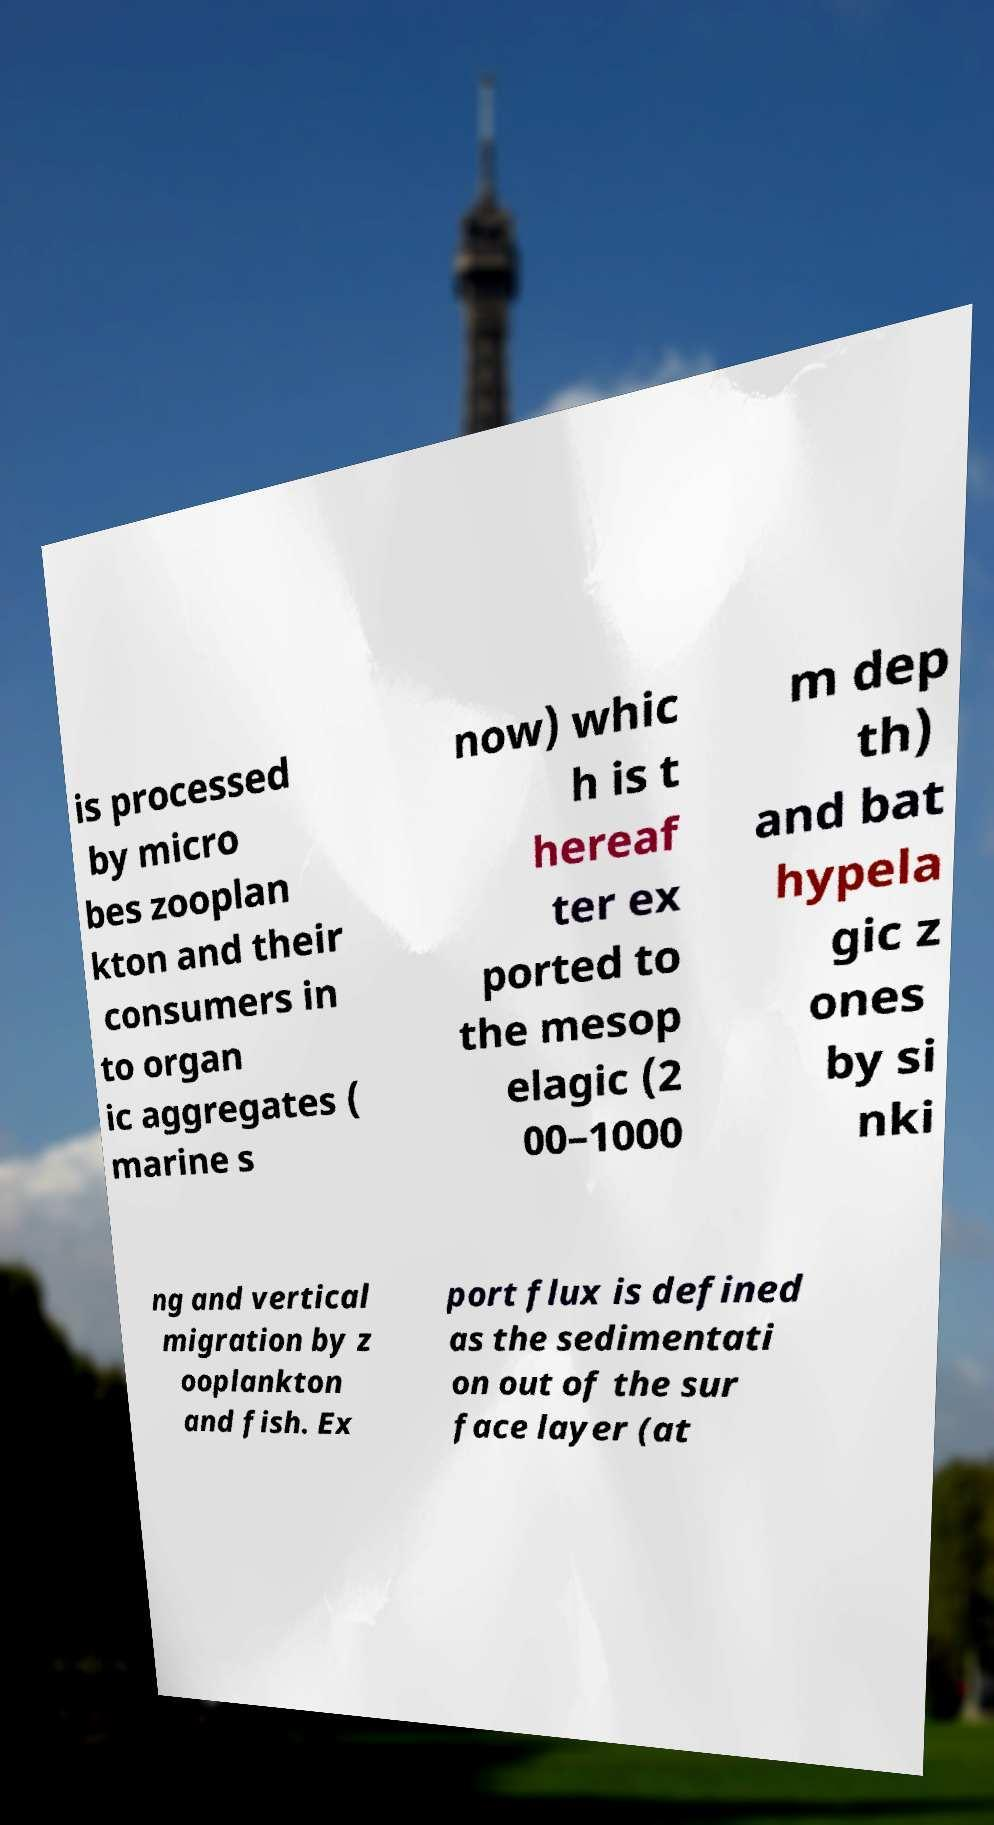There's text embedded in this image that I need extracted. Can you transcribe it verbatim? is processed by micro bes zooplan kton and their consumers in to organ ic aggregates ( marine s now) whic h is t hereaf ter ex ported to the mesop elagic (2 00–1000 m dep th) and bat hypela gic z ones by si nki ng and vertical migration by z ooplankton and fish. Ex port flux is defined as the sedimentati on out of the sur face layer (at 